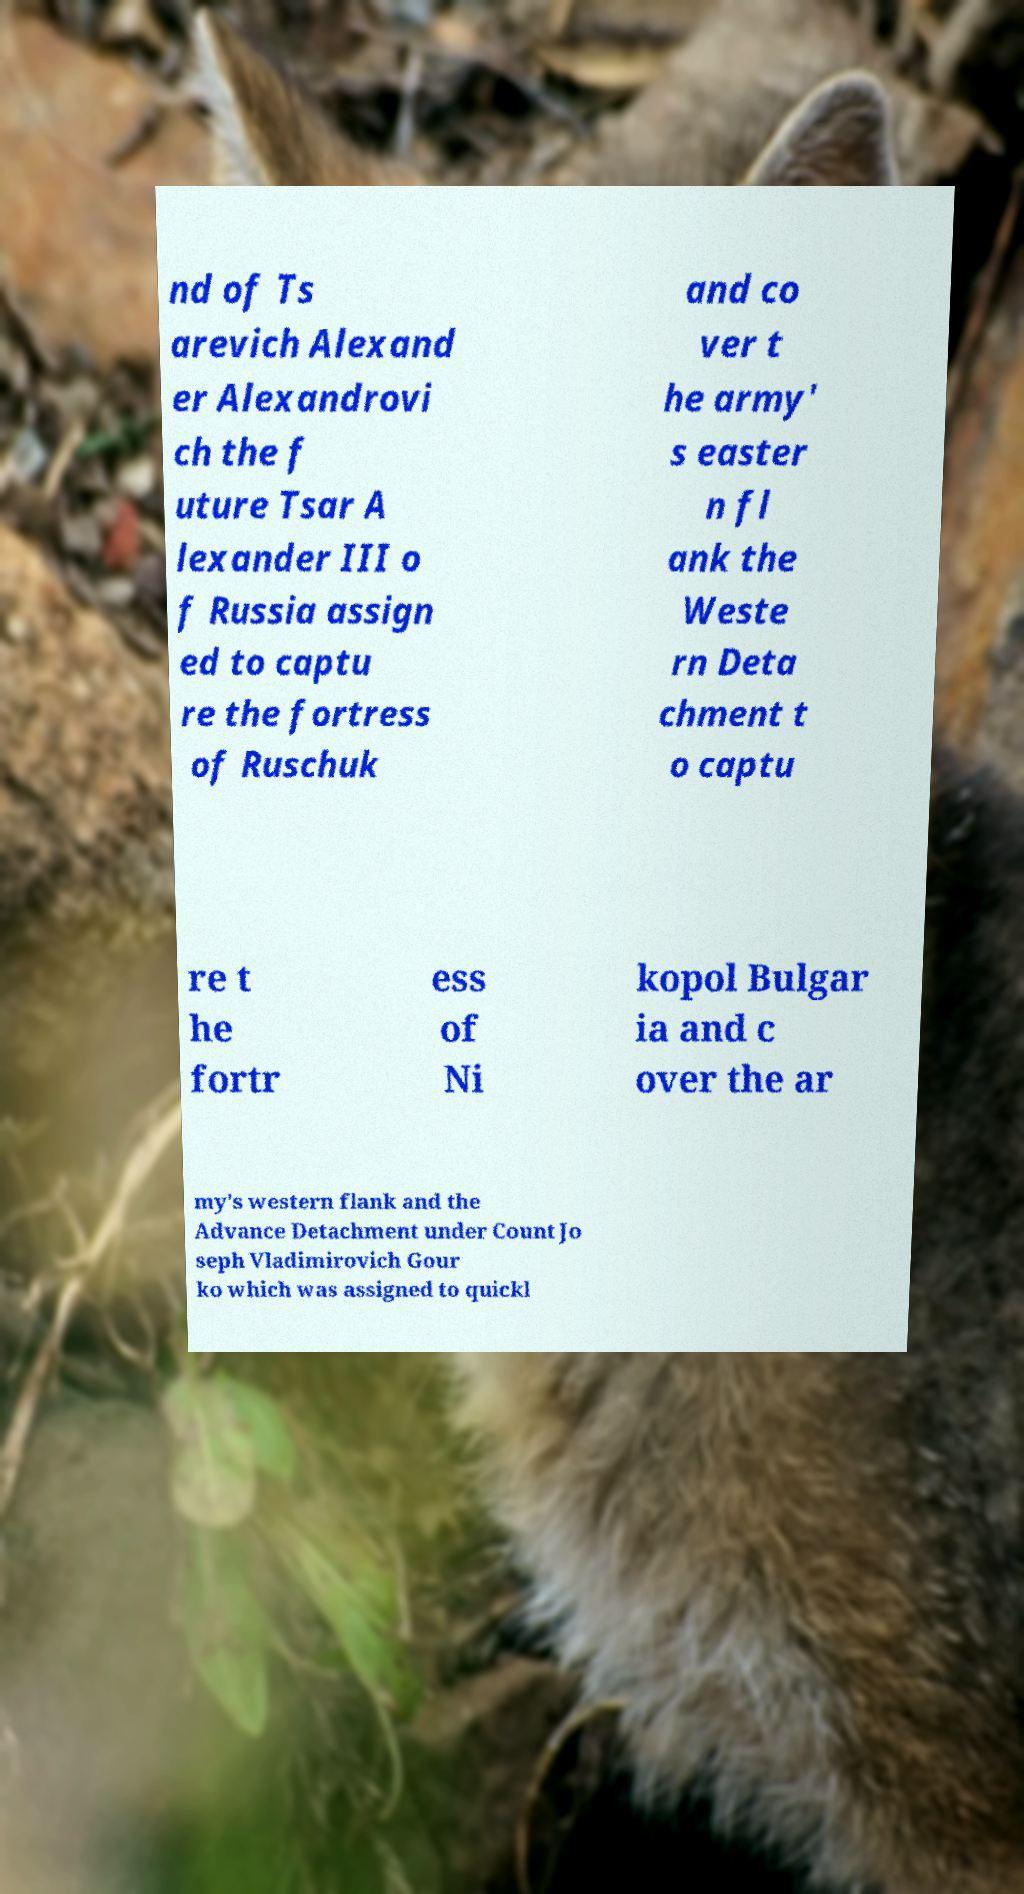Can you read and provide the text displayed in the image?This photo seems to have some interesting text. Can you extract and type it out for me? nd of Ts arevich Alexand er Alexandrovi ch the f uture Tsar A lexander III o f Russia assign ed to captu re the fortress of Ruschuk and co ver t he army' s easter n fl ank the Weste rn Deta chment t o captu re t he fortr ess of Ni kopol Bulgar ia and c over the ar my's western flank and the Advance Detachment under Count Jo seph Vladimirovich Gour ko which was assigned to quickl 